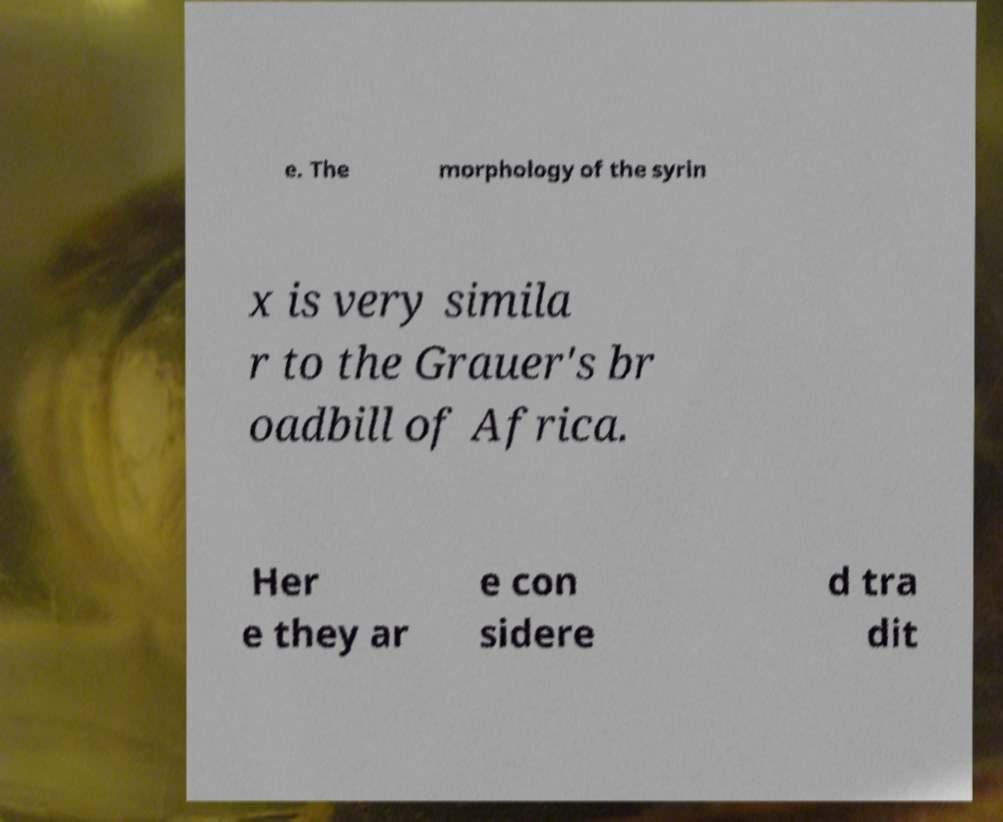For documentation purposes, I need the text within this image transcribed. Could you provide that? e. The morphology of the syrin x is very simila r to the Grauer's br oadbill of Africa. Her e they ar e con sidere d tra dit 